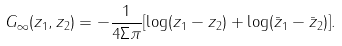<formula> <loc_0><loc_0><loc_500><loc_500>G _ { \infty } ( z _ { 1 } , z _ { 2 } ) = - \frac { 1 } { 4 \Sigma \pi } [ \log ( z _ { 1 } - z _ { 2 } ) + \log ( \bar { z } _ { 1 } - \bar { z } _ { 2 } ) ] .</formula> 